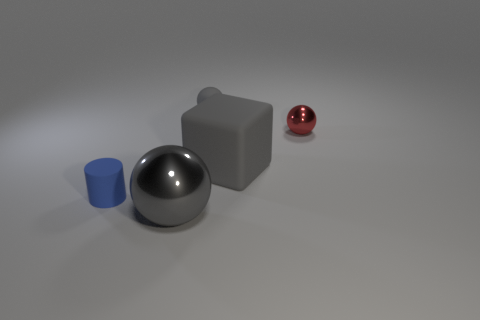Add 3 blue rubber objects. How many objects exist? 8 Subtract all balls. How many objects are left? 2 Subtract 0 cyan spheres. How many objects are left? 5 Subtract all gray blocks. Subtract all tiny cylinders. How many objects are left? 3 Add 2 gray spheres. How many gray spheres are left? 4 Add 4 tiny gray rubber balls. How many tiny gray rubber balls exist? 5 